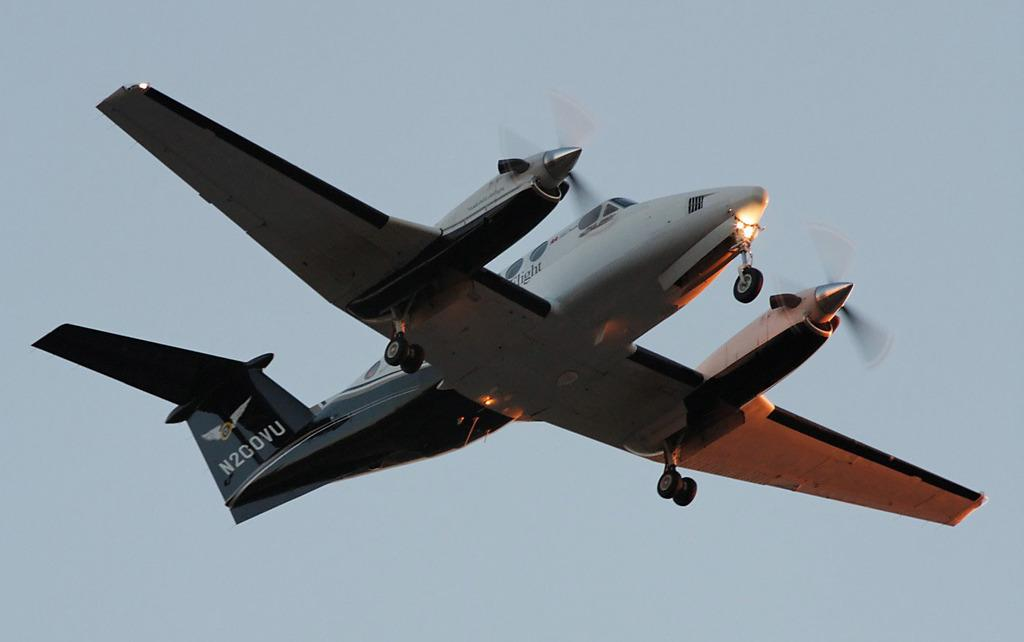What is the main subject of the image? The main subject of the image is a plane. Can you describe the plane's position in the image? The plane is in the air in the image. What can be seen in the background of the image? The sky is visible in the background of the image. What type of songs can be heard being sung by the plane in the image? There are no songs being sung by the plane in the image, as planes do not have the ability to sing songs. 